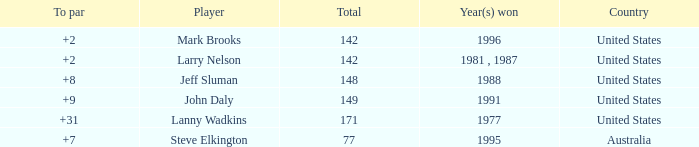Name the Total of australia and a To par smaller than 7? None. Can you parse all the data within this table? {'header': ['To par', 'Player', 'Total', 'Year(s) won', 'Country'], 'rows': [['+2', 'Mark Brooks', '142', '1996', 'United States'], ['+2', 'Larry Nelson', '142', '1981 , 1987', 'United States'], ['+8', 'Jeff Sluman', '148', '1988', 'United States'], ['+9', 'John Daly', '149', '1991', 'United States'], ['+31', 'Lanny Wadkins', '171', '1977', 'United States'], ['+7', 'Steve Elkington', '77', '1995', 'Australia']]} 